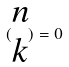Convert formula to latex. <formula><loc_0><loc_0><loc_500><loc_500>( \begin{matrix} n \\ k \end{matrix} ) = 0</formula> 